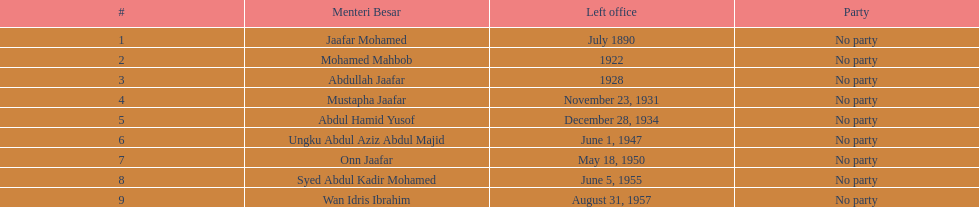Who was in office after mustapha jaafar Abdul Hamid Yusof. Could you parse the entire table? {'header': ['#', 'Menteri Besar', 'Left office', 'Party'], 'rows': [['1', 'Jaafar Mohamed', 'July 1890', 'No party'], ['2', 'Mohamed Mahbob', '1922', 'No party'], ['3', 'Abdullah Jaafar', '1928', 'No party'], ['4', 'Mustapha Jaafar', 'November 23, 1931', 'No party'], ['5', 'Abdul Hamid Yusof', 'December 28, 1934', 'No party'], ['6', 'Ungku Abdul Aziz Abdul Majid', 'June 1, 1947', 'No party'], ['7', 'Onn Jaafar', 'May 18, 1950', 'No party'], ['8', 'Syed Abdul Kadir Mohamed', 'June 5, 1955', 'No party'], ['9', 'Wan Idris Ibrahim', 'August 31, 1957', 'No party']]} 